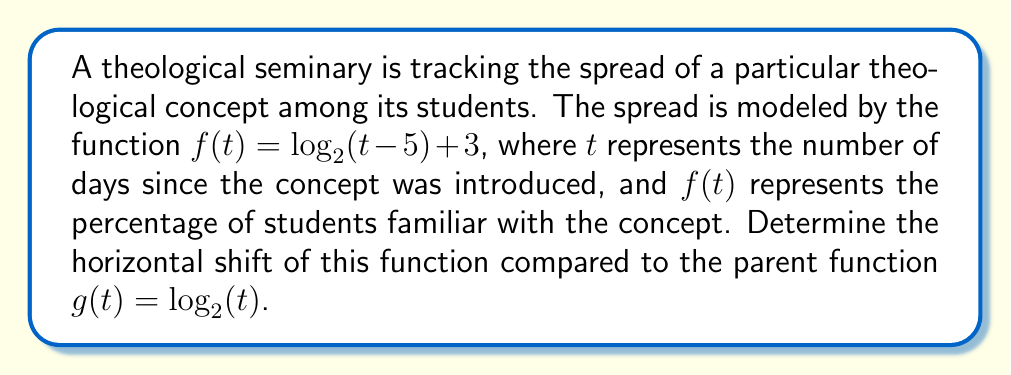What is the answer to this math problem? To determine the horizontal shift of the given logarithmic function, we need to compare it to its parent function. Let's approach this step-by-step:

1) The parent function of a logarithmic function with base 2 is $g(t) = \log_2(t)$.

2) The given function is $f(t) = \log_2(t - 5) + 3$.

3) To identify the horizontal shift, we need to focus on the expression inside the logarithm: $(t - 5)$.

4) The general form of a horizontally shifted logarithmic function is:
   $f(t) = \log_2(t - h) + k$
   where $h$ represents the horizontal shift and $k$ represents the vertical shift.

5) In our case, $t - 5$ corresponds to $t - h$ in the general form.

6) This means that $h = 5$.

7) A positive value of $h$ indicates a shift to the right.

Therefore, the function $f(t) = \log_2(t - 5) + 3$ is shifted 5 units to the right compared to the parent function $g(t) = \log_2(t)$.

Note: The vertical shift of +3 does not affect the horizontal shift.
Answer: The horizontal shift is 5 units to the right. 